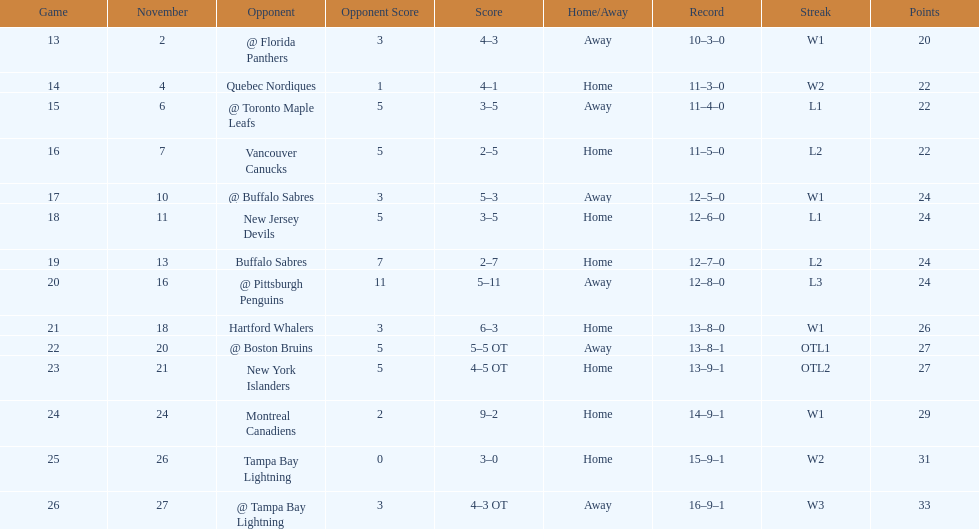Who had the most assists on the 1993-1994 flyers? Mark Recchi. 